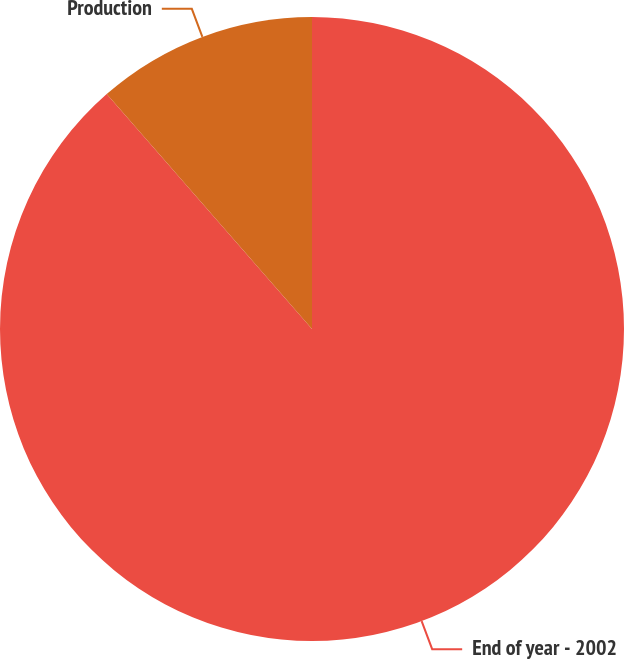Convert chart. <chart><loc_0><loc_0><loc_500><loc_500><pie_chart><fcel>End of year - 2002<fcel>Production<nl><fcel>88.57%<fcel>11.43%<nl></chart> 